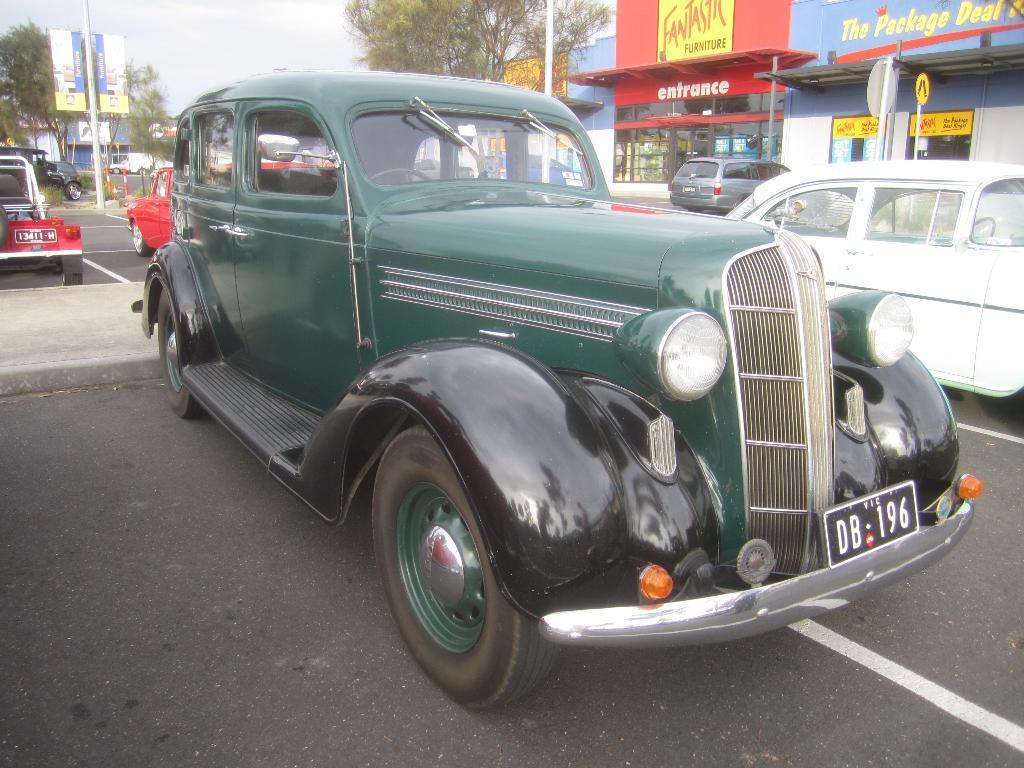How would you summarize this image in a sentence or two? In this picture we can see few vehicles on the road, in the background we can find few buildings, poles, trees and hoardings. 